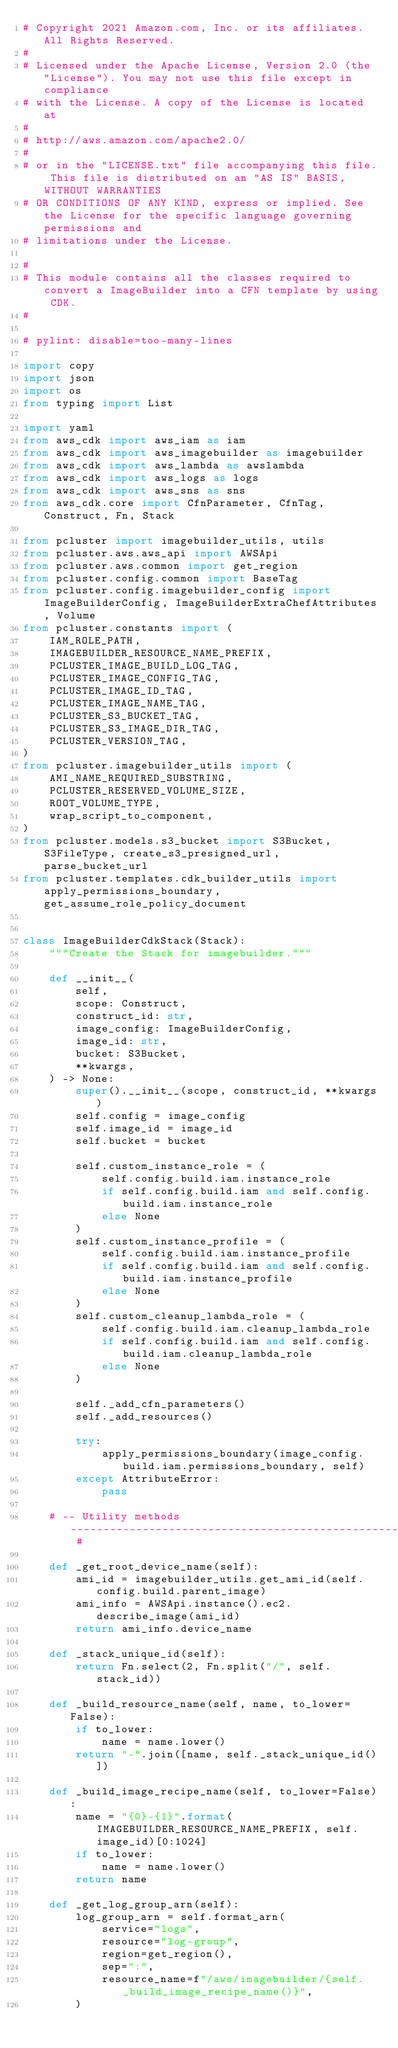Convert code to text. <code><loc_0><loc_0><loc_500><loc_500><_Python_># Copyright 2021 Amazon.com, Inc. or its affiliates. All Rights Reserved.
#
# Licensed under the Apache License, Version 2.0 (the "License"). You may not use this file except in compliance
# with the License. A copy of the License is located at
#
# http://aws.amazon.com/apache2.0/
#
# or in the "LICENSE.txt" file accompanying this file. This file is distributed on an "AS IS" BASIS, WITHOUT WARRANTIES
# OR CONDITIONS OF ANY KIND, express or implied. See the License for the specific language governing permissions and
# limitations under the License.

#
# This module contains all the classes required to convert a ImageBuilder into a CFN template by using CDK.
#

# pylint: disable=too-many-lines

import copy
import json
import os
from typing import List

import yaml
from aws_cdk import aws_iam as iam
from aws_cdk import aws_imagebuilder as imagebuilder
from aws_cdk import aws_lambda as awslambda
from aws_cdk import aws_logs as logs
from aws_cdk import aws_sns as sns
from aws_cdk.core import CfnParameter, CfnTag, Construct, Fn, Stack

from pcluster import imagebuilder_utils, utils
from pcluster.aws.aws_api import AWSApi
from pcluster.aws.common import get_region
from pcluster.config.common import BaseTag
from pcluster.config.imagebuilder_config import ImageBuilderConfig, ImageBuilderExtraChefAttributes, Volume
from pcluster.constants import (
    IAM_ROLE_PATH,
    IMAGEBUILDER_RESOURCE_NAME_PREFIX,
    PCLUSTER_IMAGE_BUILD_LOG_TAG,
    PCLUSTER_IMAGE_CONFIG_TAG,
    PCLUSTER_IMAGE_ID_TAG,
    PCLUSTER_IMAGE_NAME_TAG,
    PCLUSTER_S3_BUCKET_TAG,
    PCLUSTER_S3_IMAGE_DIR_TAG,
    PCLUSTER_VERSION_TAG,
)
from pcluster.imagebuilder_utils import (
    AMI_NAME_REQUIRED_SUBSTRING,
    PCLUSTER_RESERVED_VOLUME_SIZE,
    ROOT_VOLUME_TYPE,
    wrap_script_to_component,
)
from pcluster.models.s3_bucket import S3Bucket, S3FileType, create_s3_presigned_url, parse_bucket_url
from pcluster.templates.cdk_builder_utils import apply_permissions_boundary, get_assume_role_policy_document


class ImageBuilderCdkStack(Stack):
    """Create the Stack for imagebuilder."""

    def __init__(
        self,
        scope: Construct,
        construct_id: str,
        image_config: ImageBuilderConfig,
        image_id: str,
        bucket: S3Bucket,
        **kwargs,
    ) -> None:
        super().__init__(scope, construct_id, **kwargs)
        self.config = image_config
        self.image_id = image_id
        self.bucket = bucket

        self.custom_instance_role = (
            self.config.build.iam.instance_role
            if self.config.build.iam and self.config.build.iam.instance_role
            else None
        )
        self.custom_instance_profile = (
            self.config.build.iam.instance_profile
            if self.config.build.iam and self.config.build.iam.instance_profile
            else None
        )
        self.custom_cleanup_lambda_role = (
            self.config.build.iam.cleanup_lambda_role
            if self.config.build.iam and self.config.build.iam.cleanup_lambda_role
            else None
        )

        self._add_cfn_parameters()
        self._add_resources()

        try:
            apply_permissions_boundary(image_config.build.iam.permissions_boundary, self)
        except AttributeError:
            pass

    # -- Utility methods --------------------------------------------------------------------------------------------- #

    def _get_root_device_name(self):
        ami_id = imagebuilder_utils.get_ami_id(self.config.build.parent_image)
        ami_info = AWSApi.instance().ec2.describe_image(ami_id)
        return ami_info.device_name

    def _stack_unique_id(self):
        return Fn.select(2, Fn.split("/", self.stack_id))

    def _build_resource_name(self, name, to_lower=False):
        if to_lower:
            name = name.lower()
        return "-".join([name, self._stack_unique_id()])

    def _build_image_recipe_name(self, to_lower=False):
        name = "{0}-{1}".format(IMAGEBUILDER_RESOURCE_NAME_PREFIX, self.image_id)[0:1024]
        if to_lower:
            name = name.lower()
        return name

    def _get_log_group_arn(self):
        log_group_arn = self.format_arn(
            service="logs",
            resource="log-group",
            region=get_region(),
            sep=":",
            resource_name=f"/aws/imagebuilder/{self._build_image_recipe_name()}",
        )</code> 